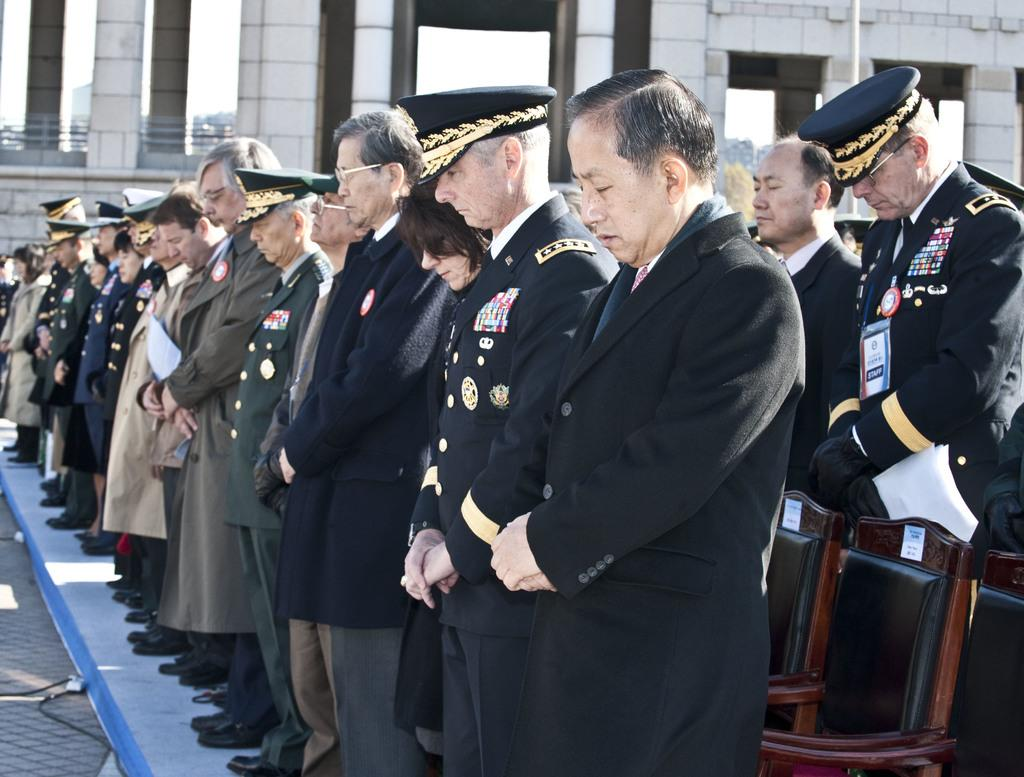What can be seen in the image? There are people standing in the image. What are the people wearing? The people are wearing uniforms and caps. What else is present in the image? There are chairs and a building in the background. What is at the bottom of the image? There is a road at the bottom of the image. How many robins are perched on the people's shoulders in the image? There are no robins present in the image. What type of addition problem can be solved using the numbers on the people's uniforms? There is no information about numbers on the people's uniforms, so it is not possible to solve an addition problem based on the image. 